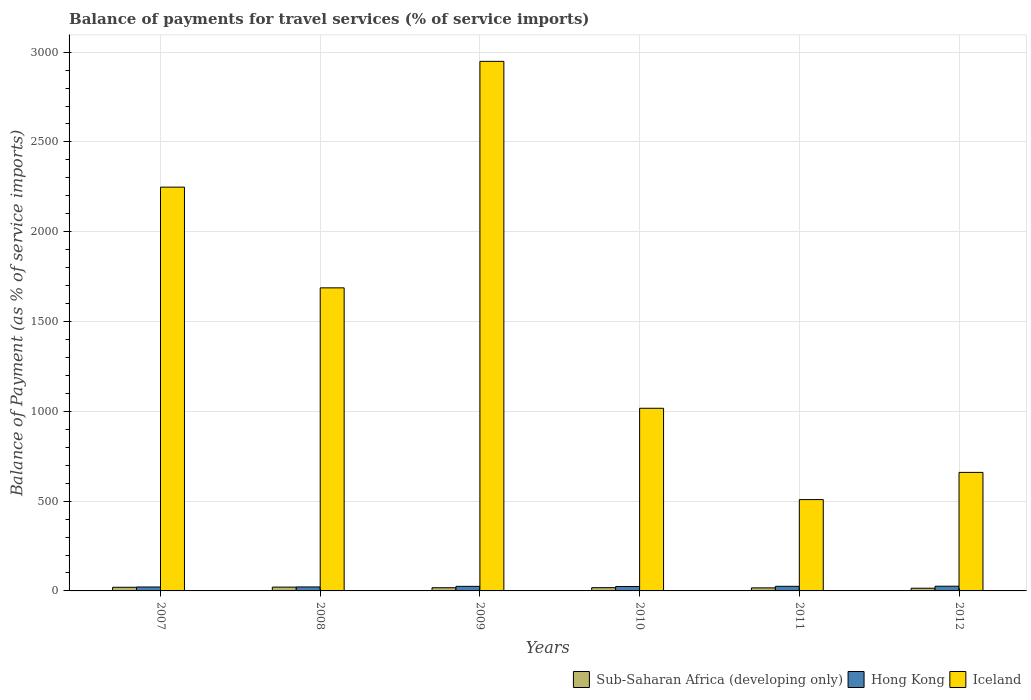How many different coloured bars are there?
Your answer should be very brief. 3. Are the number of bars per tick equal to the number of legend labels?
Your answer should be compact. Yes. How many bars are there on the 5th tick from the left?
Provide a short and direct response. 3. How many bars are there on the 2nd tick from the right?
Give a very brief answer. 3. In how many cases, is the number of bars for a given year not equal to the number of legend labels?
Keep it short and to the point. 0. What is the balance of payments for travel services in Iceland in 2009?
Offer a very short reply. 2948.8. Across all years, what is the maximum balance of payments for travel services in Sub-Saharan Africa (developing only)?
Make the answer very short. 21.18. Across all years, what is the minimum balance of payments for travel services in Hong Kong?
Ensure brevity in your answer.  21.89. In which year was the balance of payments for travel services in Iceland maximum?
Provide a short and direct response. 2009. In which year was the balance of payments for travel services in Hong Kong minimum?
Your answer should be compact. 2007. What is the total balance of payments for travel services in Iceland in the graph?
Make the answer very short. 9070.38. What is the difference between the balance of payments for travel services in Hong Kong in 2010 and that in 2012?
Keep it short and to the point. -1.55. What is the difference between the balance of payments for travel services in Sub-Saharan Africa (developing only) in 2008 and the balance of payments for travel services in Hong Kong in 2010?
Provide a succinct answer. -3.47. What is the average balance of payments for travel services in Sub-Saharan Africa (developing only) per year?
Provide a succinct answer. 18.22. In the year 2007, what is the difference between the balance of payments for travel services in Iceland and balance of payments for travel services in Hong Kong?
Ensure brevity in your answer.  2226.53. What is the ratio of the balance of payments for travel services in Hong Kong in 2007 to that in 2008?
Provide a succinct answer. 0.99. Is the balance of payments for travel services in Sub-Saharan Africa (developing only) in 2007 less than that in 2011?
Offer a very short reply. No. What is the difference between the highest and the second highest balance of payments for travel services in Iceland?
Your answer should be very brief. 700.37. What is the difference between the highest and the lowest balance of payments for travel services in Iceland?
Ensure brevity in your answer.  2440.18. In how many years, is the balance of payments for travel services in Sub-Saharan Africa (developing only) greater than the average balance of payments for travel services in Sub-Saharan Africa (developing only) taken over all years?
Ensure brevity in your answer.  2. Is the sum of the balance of payments for travel services in Hong Kong in 2008 and 2009 greater than the maximum balance of payments for travel services in Iceland across all years?
Provide a succinct answer. No. What does the 1st bar from the left in 2007 represents?
Provide a succinct answer. Sub-Saharan Africa (developing only). Is it the case that in every year, the sum of the balance of payments for travel services in Iceland and balance of payments for travel services in Hong Kong is greater than the balance of payments for travel services in Sub-Saharan Africa (developing only)?
Ensure brevity in your answer.  Yes. Are all the bars in the graph horizontal?
Ensure brevity in your answer.  No. What is the difference between two consecutive major ticks on the Y-axis?
Your response must be concise. 500. Where does the legend appear in the graph?
Make the answer very short. Bottom right. What is the title of the graph?
Give a very brief answer. Balance of payments for travel services (% of service imports). Does "Pakistan" appear as one of the legend labels in the graph?
Your answer should be compact. No. What is the label or title of the Y-axis?
Your answer should be compact. Balance of Payment (as % of service imports). What is the Balance of Payment (as % of service imports) of Sub-Saharan Africa (developing only) in 2007?
Provide a short and direct response. 20.3. What is the Balance of Payment (as % of service imports) of Hong Kong in 2007?
Give a very brief answer. 21.89. What is the Balance of Payment (as % of service imports) of Iceland in 2007?
Provide a short and direct response. 2248.42. What is the Balance of Payment (as % of service imports) of Sub-Saharan Africa (developing only) in 2008?
Offer a terse response. 21.18. What is the Balance of Payment (as % of service imports) of Hong Kong in 2008?
Offer a very short reply. 22.16. What is the Balance of Payment (as % of service imports) in Iceland in 2008?
Offer a terse response. 1687.56. What is the Balance of Payment (as % of service imports) of Sub-Saharan Africa (developing only) in 2009?
Keep it short and to the point. 17.69. What is the Balance of Payment (as % of service imports) of Hong Kong in 2009?
Provide a succinct answer. 25.44. What is the Balance of Payment (as % of service imports) in Iceland in 2009?
Offer a very short reply. 2948.8. What is the Balance of Payment (as % of service imports) of Sub-Saharan Africa (developing only) in 2010?
Give a very brief answer. 18.14. What is the Balance of Payment (as % of service imports) of Hong Kong in 2010?
Provide a short and direct response. 24.66. What is the Balance of Payment (as % of service imports) in Iceland in 2010?
Provide a succinct answer. 1017.05. What is the Balance of Payment (as % of service imports) in Sub-Saharan Africa (developing only) in 2011?
Offer a very short reply. 16.9. What is the Balance of Payment (as % of service imports) in Hong Kong in 2011?
Offer a very short reply. 25.62. What is the Balance of Payment (as % of service imports) of Iceland in 2011?
Make the answer very short. 508.61. What is the Balance of Payment (as % of service imports) in Sub-Saharan Africa (developing only) in 2012?
Offer a terse response. 15.08. What is the Balance of Payment (as % of service imports) of Hong Kong in 2012?
Ensure brevity in your answer.  26.2. What is the Balance of Payment (as % of service imports) in Iceland in 2012?
Your response must be concise. 659.94. Across all years, what is the maximum Balance of Payment (as % of service imports) of Sub-Saharan Africa (developing only)?
Your answer should be very brief. 21.18. Across all years, what is the maximum Balance of Payment (as % of service imports) of Hong Kong?
Provide a succinct answer. 26.2. Across all years, what is the maximum Balance of Payment (as % of service imports) in Iceland?
Give a very brief answer. 2948.8. Across all years, what is the minimum Balance of Payment (as % of service imports) in Sub-Saharan Africa (developing only)?
Your answer should be very brief. 15.08. Across all years, what is the minimum Balance of Payment (as % of service imports) in Hong Kong?
Keep it short and to the point. 21.89. Across all years, what is the minimum Balance of Payment (as % of service imports) in Iceland?
Your response must be concise. 508.61. What is the total Balance of Payment (as % of service imports) in Sub-Saharan Africa (developing only) in the graph?
Give a very brief answer. 109.29. What is the total Balance of Payment (as % of service imports) in Hong Kong in the graph?
Provide a succinct answer. 145.97. What is the total Balance of Payment (as % of service imports) of Iceland in the graph?
Make the answer very short. 9070.38. What is the difference between the Balance of Payment (as % of service imports) in Sub-Saharan Africa (developing only) in 2007 and that in 2008?
Provide a succinct answer. -0.88. What is the difference between the Balance of Payment (as % of service imports) of Hong Kong in 2007 and that in 2008?
Offer a very short reply. -0.27. What is the difference between the Balance of Payment (as % of service imports) of Iceland in 2007 and that in 2008?
Make the answer very short. 560.86. What is the difference between the Balance of Payment (as % of service imports) of Sub-Saharan Africa (developing only) in 2007 and that in 2009?
Your response must be concise. 2.61. What is the difference between the Balance of Payment (as % of service imports) in Hong Kong in 2007 and that in 2009?
Make the answer very short. -3.55. What is the difference between the Balance of Payment (as % of service imports) in Iceland in 2007 and that in 2009?
Provide a succinct answer. -700.37. What is the difference between the Balance of Payment (as % of service imports) of Sub-Saharan Africa (developing only) in 2007 and that in 2010?
Ensure brevity in your answer.  2.16. What is the difference between the Balance of Payment (as % of service imports) of Hong Kong in 2007 and that in 2010?
Offer a very short reply. -2.77. What is the difference between the Balance of Payment (as % of service imports) in Iceland in 2007 and that in 2010?
Make the answer very short. 1231.38. What is the difference between the Balance of Payment (as % of service imports) of Sub-Saharan Africa (developing only) in 2007 and that in 2011?
Offer a terse response. 3.4. What is the difference between the Balance of Payment (as % of service imports) in Hong Kong in 2007 and that in 2011?
Provide a short and direct response. -3.73. What is the difference between the Balance of Payment (as % of service imports) of Iceland in 2007 and that in 2011?
Give a very brief answer. 1739.81. What is the difference between the Balance of Payment (as % of service imports) of Sub-Saharan Africa (developing only) in 2007 and that in 2012?
Your response must be concise. 5.22. What is the difference between the Balance of Payment (as % of service imports) in Hong Kong in 2007 and that in 2012?
Your answer should be compact. -4.31. What is the difference between the Balance of Payment (as % of service imports) of Iceland in 2007 and that in 2012?
Provide a succinct answer. 1588.48. What is the difference between the Balance of Payment (as % of service imports) in Sub-Saharan Africa (developing only) in 2008 and that in 2009?
Ensure brevity in your answer.  3.5. What is the difference between the Balance of Payment (as % of service imports) of Hong Kong in 2008 and that in 2009?
Keep it short and to the point. -3.28. What is the difference between the Balance of Payment (as % of service imports) in Iceland in 2008 and that in 2009?
Make the answer very short. -1261.23. What is the difference between the Balance of Payment (as % of service imports) of Sub-Saharan Africa (developing only) in 2008 and that in 2010?
Ensure brevity in your answer.  3.04. What is the difference between the Balance of Payment (as % of service imports) of Hong Kong in 2008 and that in 2010?
Offer a terse response. -2.49. What is the difference between the Balance of Payment (as % of service imports) in Iceland in 2008 and that in 2010?
Provide a short and direct response. 670.52. What is the difference between the Balance of Payment (as % of service imports) of Sub-Saharan Africa (developing only) in 2008 and that in 2011?
Provide a short and direct response. 4.29. What is the difference between the Balance of Payment (as % of service imports) in Hong Kong in 2008 and that in 2011?
Your answer should be compact. -3.45. What is the difference between the Balance of Payment (as % of service imports) in Iceland in 2008 and that in 2011?
Keep it short and to the point. 1178.95. What is the difference between the Balance of Payment (as % of service imports) in Sub-Saharan Africa (developing only) in 2008 and that in 2012?
Offer a very short reply. 6.1. What is the difference between the Balance of Payment (as % of service imports) in Hong Kong in 2008 and that in 2012?
Ensure brevity in your answer.  -4.04. What is the difference between the Balance of Payment (as % of service imports) of Iceland in 2008 and that in 2012?
Your answer should be very brief. 1027.62. What is the difference between the Balance of Payment (as % of service imports) in Sub-Saharan Africa (developing only) in 2009 and that in 2010?
Provide a short and direct response. -0.45. What is the difference between the Balance of Payment (as % of service imports) in Hong Kong in 2009 and that in 2010?
Offer a very short reply. 0.79. What is the difference between the Balance of Payment (as % of service imports) of Iceland in 2009 and that in 2010?
Ensure brevity in your answer.  1931.75. What is the difference between the Balance of Payment (as % of service imports) of Sub-Saharan Africa (developing only) in 2009 and that in 2011?
Give a very brief answer. 0.79. What is the difference between the Balance of Payment (as % of service imports) of Hong Kong in 2009 and that in 2011?
Ensure brevity in your answer.  -0.17. What is the difference between the Balance of Payment (as % of service imports) of Iceland in 2009 and that in 2011?
Your response must be concise. 2440.18. What is the difference between the Balance of Payment (as % of service imports) in Sub-Saharan Africa (developing only) in 2009 and that in 2012?
Make the answer very short. 2.6. What is the difference between the Balance of Payment (as % of service imports) in Hong Kong in 2009 and that in 2012?
Make the answer very short. -0.76. What is the difference between the Balance of Payment (as % of service imports) of Iceland in 2009 and that in 2012?
Your answer should be compact. 2288.86. What is the difference between the Balance of Payment (as % of service imports) in Sub-Saharan Africa (developing only) in 2010 and that in 2011?
Your answer should be compact. 1.24. What is the difference between the Balance of Payment (as % of service imports) of Hong Kong in 2010 and that in 2011?
Your answer should be compact. -0.96. What is the difference between the Balance of Payment (as % of service imports) in Iceland in 2010 and that in 2011?
Your answer should be compact. 508.44. What is the difference between the Balance of Payment (as % of service imports) of Sub-Saharan Africa (developing only) in 2010 and that in 2012?
Ensure brevity in your answer.  3.06. What is the difference between the Balance of Payment (as % of service imports) in Hong Kong in 2010 and that in 2012?
Offer a terse response. -1.55. What is the difference between the Balance of Payment (as % of service imports) in Iceland in 2010 and that in 2012?
Your answer should be very brief. 357.11. What is the difference between the Balance of Payment (as % of service imports) of Sub-Saharan Africa (developing only) in 2011 and that in 2012?
Offer a very short reply. 1.81. What is the difference between the Balance of Payment (as % of service imports) of Hong Kong in 2011 and that in 2012?
Provide a short and direct response. -0.59. What is the difference between the Balance of Payment (as % of service imports) of Iceland in 2011 and that in 2012?
Provide a succinct answer. -151.33. What is the difference between the Balance of Payment (as % of service imports) of Sub-Saharan Africa (developing only) in 2007 and the Balance of Payment (as % of service imports) of Hong Kong in 2008?
Offer a very short reply. -1.86. What is the difference between the Balance of Payment (as % of service imports) of Sub-Saharan Africa (developing only) in 2007 and the Balance of Payment (as % of service imports) of Iceland in 2008?
Offer a terse response. -1667.26. What is the difference between the Balance of Payment (as % of service imports) of Hong Kong in 2007 and the Balance of Payment (as % of service imports) of Iceland in 2008?
Give a very brief answer. -1665.67. What is the difference between the Balance of Payment (as % of service imports) of Sub-Saharan Africa (developing only) in 2007 and the Balance of Payment (as % of service imports) of Hong Kong in 2009?
Give a very brief answer. -5.14. What is the difference between the Balance of Payment (as % of service imports) in Sub-Saharan Africa (developing only) in 2007 and the Balance of Payment (as % of service imports) in Iceland in 2009?
Your answer should be compact. -2928.5. What is the difference between the Balance of Payment (as % of service imports) of Hong Kong in 2007 and the Balance of Payment (as % of service imports) of Iceland in 2009?
Your response must be concise. -2926.91. What is the difference between the Balance of Payment (as % of service imports) of Sub-Saharan Africa (developing only) in 2007 and the Balance of Payment (as % of service imports) of Hong Kong in 2010?
Provide a succinct answer. -4.36. What is the difference between the Balance of Payment (as % of service imports) of Sub-Saharan Africa (developing only) in 2007 and the Balance of Payment (as % of service imports) of Iceland in 2010?
Your answer should be very brief. -996.75. What is the difference between the Balance of Payment (as % of service imports) of Hong Kong in 2007 and the Balance of Payment (as % of service imports) of Iceland in 2010?
Make the answer very short. -995.16. What is the difference between the Balance of Payment (as % of service imports) in Sub-Saharan Africa (developing only) in 2007 and the Balance of Payment (as % of service imports) in Hong Kong in 2011?
Your response must be concise. -5.32. What is the difference between the Balance of Payment (as % of service imports) of Sub-Saharan Africa (developing only) in 2007 and the Balance of Payment (as % of service imports) of Iceland in 2011?
Ensure brevity in your answer.  -488.31. What is the difference between the Balance of Payment (as % of service imports) in Hong Kong in 2007 and the Balance of Payment (as % of service imports) in Iceland in 2011?
Give a very brief answer. -486.72. What is the difference between the Balance of Payment (as % of service imports) of Sub-Saharan Africa (developing only) in 2007 and the Balance of Payment (as % of service imports) of Hong Kong in 2012?
Your answer should be very brief. -5.9. What is the difference between the Balance of Payment (as % of service imports) in Sub-Saharan Africa (developing only) in 2007 and the Balance of Payment (as % of service imports) in Iceland in 2012?
Your answer should be compact. -639.64. What is the difference between the Balance of Payment (as % of service imports) of Hong Kong in 2007 and the Balance of Payment (as % of service imports) of Iceland in 2012?
Provide a short and direct response. -638.05. What is the difference between the Balance of Payment (as % of service imports) in Sub-Saharan Africa (developing only) in 2008 and the Balance of Payment (as % of service imports) in Hong Kong in 2009?
Provide a succinct answer. -4.26. What is the difference between the Balance of Payment (as % of service imports) in Sub-Saharan Africa (developing only) in 2008 and the Balance of Payment (as % of service imports) in Iceland in 2009?
Your response must be concise. -2927.61. What is the difference between the Balance of Payment (as % of service imports) in Hong Kong in 2008 and the Balance of Payment (as % of service imports) in Iceland in 2009?
Provide a short and direct response. -2926.63. What is the difference between the Balance of Payment (as % of service imports) in Sub-Saharan Africa (developing only) in 2008 and the Balance of Payment (as % of service imports) in Hong Kong in 2010?
Your answer should be compact. -3.47. What is the difference between the Balance of Payment (as % of service imports) of Sub-Saharan Africa (developing only) in 2008 and the Balance of Payment (as % of service imports) of Iceland in 2010?
Provide a short and direct response. -995.86. What is the difference between the Balance of Payment (as % of service imports) of Hong Kong in 2008 and the Balance of Payment (as % of service imports) of Iceland in 2010?
Offer a very short reply. -994.88. What is the difference between the Balance of Payment (as % of service imports) in Sub-Saharan Africa (developing only) in 2008 and the Balance of Payment (as % of service imports) in Hong Kong in 2011?
Offer a terse response. -4.43. What is the difference between the Balance of Payment (as % of service imports) of Sub-Saharan Africa (developing only) in 2008 and the Balance of Payment (as % of service imports) of Iceland in 2011?
Offer a terse response. -487.43. What is the difference between the Balance of Payment (as % of service imports) in Hong Kong in 2008 and the Balance of Payment (as % of service imports) in Iceland in 2011?
Offer a very short reply. -486.45. What is the difference between the Balance of Payment (as % of service imports) of Sub-Saharan Africa (developing only) in 2008 and the Balance of Payment (as % of service imports) of Hong Kong in 2012?
Your answer should be very brief. -5.02. What is the difference between the Balance of Payment (as % of service imports) in Sub-Saharan Africa (developing only) in 2008 and the Balance of Payment (as % of service imports) in Iceland in 2012?
Your answer should be compact. -638.76. What is the difference between the Balance of Payment (as % of service imports) in Hong Kong in 2008 and the Balance of Payment (as % of service imports) in Iceland in 2012?
Provide a succinct answer. -637.78. What is the difference between the Balance of Payment (as % of service imports) in Sub-Saharan Africa (developing only) in 2009 and the Balance of Payment (as % of service imports) in Hong Kong in 2010?
Offer a terse response. -6.97. What is the difference between the Balance of Payment (as % of service imports) of Sub-Saharan Africa (developing only) in 2009 and the Balance of Payment (as % of service imports) of Iceland in 2010?
Your answer should be compact. -999.36. What is the difference between the Balance of Payment (as % of service imports) of Hong Kong in 2009 and the Balance of Payment (as % of service imports) of Iceland in 2010?
Give a very brief answer. -991.6. What is the difference between the Balance of Payment (as % of service imports) of Sub-Saharan Africa (developing only) in 2009 and the Balance of Payment (as % of service imports) of Hong Kong in 2011?
Offer a terse response. -7.93. What is the difference between the Balance of Payment (as % of service imports) of Sub-Saharan Africa (developing only) in 2009 and the Balance of Payment (as % of service imports) of Iceland in 2011?
Provide a short and direct response. -490.92. What is the difference between the Balance of Payment (as % of service imports) of Hong Kong in 2009 and the Balance of Payment (as % of service imports) of Iceland in 2011?
Provide a short and direct response. -483.17. What is the difference between the Balance of Payment (as % of service imports) of Sub-Saharan Africa (developing only) in 2009 and the Balance of Payment (as % of service imports) of Hong Kong in 2012?
Your answer should be compact. -8.52. What is the difference between the Balance of Payment (as % of service imports) of Sub-Saharan Africa (developing only) in 2009 and the Balance of Payment (as % of service imports) of Iceland in 2012?
Offer a very short reply. -642.25. What is the difference between the Balance of Payment (as % of service imports) in Hong Kong in 2009 and the Balance of Payment (as % of service imports) in Iceland in 2012?
Provide a succinct answer. -634.5. What is the difference between the Balance of Payment (as % of service imports) in Sub-Saharan Africa (developing only) in 2010 and the Balance of Payment (as % of service imports) in Hong Kong in 2011?
Give a very brief answer. -7.48. What is the difference between the Balance of Payment (as % of service imports) of Sub-Saharan Africa (developing only) in 2010 and the Balance of Payment (as % of service imports) of Iceland in 2011?
Make the answer very short. -490.47. What is the difference between the Balance of Payment (as % of service imports) of Hong Kong in 2010 and the Balance of Payment (as % of service imports) of Iceland in 2011?
Give a very brief answer. -483.96. What is the difference between the Balance of Payment (as % of service imports) of Sub-Saharan Africa (developing only) in 2010 and the Balance of Payment (as % of service imports) of Hong Kong in 2012?
Keep it short and to the point. -8.06. What is the difference between the Balance of Payment (as % of service imports) of Sub-Saharan Africa (developing only) in 2010 and the Balance of Payment (as % of service imports) of Iceland in 2012?
Ensure brevity in your answer.  -641.8. What is the difference between the Balance of Payment (as % of service imports) in Hong Kong in 2010 and the Balance of Payment (as % of service imports) in Iceland in 2012?
Offer a very short reply. -635.28. What is the difference between the Balance of Payment (as % of service imports) of Sub-Saharan Africa (developing only) in 2011 and the Balance of Payment (as % of service imports) of Hong Kong in 2012?
Make the answer very short. -9.31. What is the difference between the Balance of Payment (as % of service imports) in Sub-Saharan Africa (developing only) in 2011 and the Balance of Payment (as % of service imports) in Iceland in 2012?
Offer a very short reply. -643.04. What is the difference between the Balance of Payment (as % of service imports) in Hong Kong in 2011 and the Balance of Payment (as % of service imports) in Iceland in 2012?
Offer a very short reply. -634.32. What is the average Balance of Payment (as % of service imports) in Sub-Saharan Africa (developing only) per year?
Make the answer very short. 18.22. What is the average Balance of Payment (as % of service imports) in Hong Kong per year?
Make the answer very short. 24.33. What is the average Balance of Payment (as % of service imports) in Iceland per year?
Your response must be concise. 1511.73. In the year 2007, what is the difference between the Balance of Payment (as % of service imports) of Sub-Saharan Africa (developing only) and Balance of Payment (as % of service imports) of Hong Kong?
Provide a succinct answer. -1.59. In the year 2007, what is the difference between the Balance of Payment (as % of service imports) of Sub-Saharan Africa (developing only) and Balance of Payment (as % of service imports) of Iceland?
Offer a very short reply. -2228.12. In the year 2007, what is the difference between the Balance of Payment (as % of service imports) of Hong Kong and Balance of Payment (as % of service imports) of Iceland?
Give a very brief answer. -2226.53. In the year 2008, what is the difference between the Balance of Payment (as % of service imports) in Sub-Saharan Africa (developing only) and Balance of Payment (as % of service imports) in Hong Kong?
Provide a succinct answer. -0.98. In the year 2008, what is the difference between the Balance of Payment (as % of service imports) in Sub-Saharan Africa (developing only) and Balance of Payment (as % of service imports) in Iceland?
Keep it short and to the point. -1666.38. In the year 2008, what is the difference between the Balance of Payment (as % of service imports) of Hong Kong and Balance of Payment (as % of service imports) of Iceland?
Your answer should be very brief. -1665.4. In the year 2009, what is the difference between the Balance of Payment (as % of service imports) in Sub-Saharan Africa (developing only) and Balance of Payment (as % of service imports) in Hong Kong?
Your answer should be compact. -7.75. In the year 2009, what is the difference between the Balance of Payment (as % of service imports) of Sub-Saharan Africa (developing only) and Balance of Payment (as % of service imports) of Iceland?
Your answer should be compact. -2931.11. In the year 2009, what is the difference between the Balance of Payment (as % of service imports) of Hong Kong and Balance of Payment (as % of service imports) of Iceland?
Offer a very short reply. -2923.35. In the year 2010, what is the difference between the Balance of Payment (as % of service imports) in Sub-Saharan Africa (developing only) and Balance of Payment (as % of service imports) in Hong Kong?
Your answer should be compact. -6.51. In the year 2010, what is the difference between the Balance of Payment (as % of service imports) of Sub-Saharan Africa (developing only) and Balance of Payment (as % of service imports) of Iceland?
Give a very brief answer. -998.9. In the year 2010, what is the difference between the Balance of Payment (as % of service imports) in Hong Kong and Balance of Payment (as % of service imports) in Iceland?
Your answer should be compact. -992.39. In the year 2011, what is the difference between the Balance of Payment (as % of service imports) in Sub-Saharan Africa (developing only) and Balance of Payment (as % of service imports) in Hong Kong?
Give a very brief answer. -8.72. In the year 2011, what is the difference between the Balance of Payment (as % of service imports) in Sub-Saharan Africa (developing only) and Balance of Payment (as % of service imports) in Iceland?
Your answer should be very brief. -491.71. In the year 2011, what is the difference between the Balance of Payment (as % of service imports) in Hong Kong and Balance of Payment (as % of service imports) in Iceland?
Provide a succinct answer. -482.99. In the year 2012, what is the difference between the Balance of Payment (as % of service imports) of Sub-Saharan Africa (developing only) and Balance of Payment (as % of service imports) of Hong Kong?
Provide a short and direct response. -11.12. In the year 2012, what is the difference between the Balance of Payment (as % of service imports) in Sub-Saharan Africa (developing only) and Balance of Payment (as % of service imports) in Iceland?
Offer a very short reply. -644.86. In the year 2012, what is the difference between the Balance of Payment (as % of service imports) in Hong Kong and Balance of Payment (as % of service imports) in Iceland?
Provide a succinct answer. -633.74. What is the ratio of the Balance of Payment (as % of service imports) of Sub-Saharan Africa (developing only) in 2007 to that in 2008?
Offer a very short reply. 0.96. What is the ratio of the Balance of Payment (as % of service imports) in Hong Kong in 2007 to that in 2008?
Your answer should be very brief. 0.99. What is the ratio of the Balance of Payment (as % of service imports) in Iceland in 2007 to that in 2008?
Your answer should be very brief. 1.33. What is the ratio of the Balance of Payment (as % of service imports) in Sub-Saharan Africa (developing only) in 2007 to that in 2009?
Provide a succinct answer. 1.15. What is the ratio of the Balance of Payment (as % of service imports) of Hong Kong in 2007 to that in 2009?
Your response must be concise. 0.86. What is the ratio of the Balance of Payment (as % of service imports) of Iceland in 2007 to that in 2009?
Make the answer very short. 0.76. What is the ratio of the Balance of Payment (as % of service imports) in Sub-Saharan Africa (developing only) in 2007 to that in 2010?
Provide a short and direct response. 1.12. What is the ratio of the Balance of Payment (as % of service imports) in Hong Kong in 2007 to that in 2010?
Your response must be concise. 0.89. What is the ratio of the Balance of Payment (as % of service imports) of Iceland in 2007 to that in 2010?
Your response must be concise. 2.21. What is the ratio of the Balance of Payment (as % of service imports) in Sub-Saharan Africa (developing only) in 2007 to that in 2011?
Keep it short and to the point. 1.2. What is the ratio of the Balance of Payment (as % of service imports) of Hong Kong in 2007 to that in 2011?
Provide a succinct answer. 0.85. What is the ratio of the Balance of Payment (as % of service imports) of Iceland in 2007 to that in 2011?
Ensure brevity in your answer.  4.42. What is the ratio of the Balance of Payment (as % of service imports) of Sub-Saharan Africa (developing only) in 2007 to that in 2012?
Offer a very short reply. 1.35. What is the ratio of the Balance of Payment (as % of service imports) in Hong Kong in 2007 to that in 2012?
Ensure brevity in your answer.  0.84. What is the ratio of the Balance of Payment (as % of service imports) in Iceland in 2007 to that in 2012?
Offer a very short reply. 3.41. What is the ratio of the Balance of Payment (as % of service imports) in Sub-Saharan Africa (developing only) in 2008 to that in 2009?
Provide a short and direct response. 1.2. What is the ratio of the Balance of Payment (as % of service imports) in Hong Kong in 2008 to that in 2009?
Provide a succinct answer. 0.87. What is the ratio of the Balance of Payment (as % of service imports) of Iceland in 2008 to that in 2009?
Ensure brevity in your answer.  0.57. What is the ratio of the Balance of Payment (as % of service imports) in Sub-Saharan Africa (developing only) in 2008 to that in 2010?
Your response must be concise. 1.17. What is the ratio of the Balance of Payment (as % of service imports) of Hong Kong in 2008 to that in 2010?
Ensure brevity in your answer.  0.9. What is the ratio of the Balance of Payment (as % of service imports) in Iceland in 2008 to that in 2010?
Offer a very short reply. 1.66. What is the ratio of the Balance of Payment (as % of service imports) in Sub-Saharan Africa (developing only) in 2008 to that in 2011?
Keep it short and to the point. 1.25. What is the ratio of the Balance of Payment (as % of service imports) of Hong Kong in 2008 to that in 2011?
Your answer should be compact. 0.87. What is the ratio of the Balance of Payment (as % of service imports) of Iceland in 2008 to that in 2011?
Offer a very short reply. 3.32. What is the ratio of the Balance of Payment (as % of service imports) of Sub-Saharan Africa (developing only) in 2008 to that in 2012?
Keep it short and to the point. 1.4. What is the ratio of the Balance of Payment (as % of service imports) in Hong Kong in 2008 to that in 2012?
Provide a short and direct response. 0.85. What is the ratio of the Balance of Payment (as % of service imports) of Iceland in 2008 to that in 2012?
Make the answer very short. 2.56. What is the ratio of the Balance of Payment (as % of service imports) in Sub-Saharan Africa (developing only) in 2009 to that in 2010?
Offer a terse response. 0.97. What is the ratio of the Balance of Payment (as % of service imports) in Hong Kong in 2009 to that in 2010?
Provide a short and direct response. 1.03. What is the ratio of the Balance of Payment (as % of service imports) of Iceland in 2009 to that in 2010?
Keep it short and to the point. 2.9. What is the ratio of the Balance of Payment (as % of service imports) of Sub-Saharan Africa (developing only) in 2009 to that in 2011?
Your answer should be compact. 1.05. What is the ratio of the Balance of Payment (as % of service imports) in Hong Kong in 2009 to that in 2011?
Provide a short and direct response. 0.99. What is the ratio of the Balance of Payment (as % of service imports) in Iceland in 2009 to that in 2011?
Your response must be concise. 5.8. What is the ratio of the Balance of Payment (as % of service imports) of Sub-Saharan Africa (developing only) in 2009 to that in 2012?
Your response must be concise. 1.17. What is the ratio of the Balance of Payment (as % of service imports) in Iceland in 2009 to that in 2012?
Your response must be concise. 4.47. What is the ratio of the Balance of Payment (as % of service imports) of Sub-Saharan Africa (developing only) in 2010 to that in 2011?
Offer a very short reply. 1.07. What is the ratio of the Balance of Payment (as % of service imports) in Hong Kong in 2010 to that in 2011?
Ensure brevity in your answer.  0.96. What is the ratio of the Balance of Payment (as % of service imports) in Iceland in 2010 to that in 2011?
Provide a short and direct response. 2. What is the ratio of the Balance of Payment (as % of service imports) of Sub-Saharan Africa (developing only) in 2010 to that in 2012?
Offer a terse response. 1.2. What is the ratio of the Balance of Payment (as % of service imports) of Hong Kong in 2010 to that in 2012?
Ensure brevity in your answer.  0.94. What is the ratio of the Balance of Payment (as % of service imports) in Iceland in 2010 to that in 2012?
Give a very brief answer. 1.54. What is the ratio of the Balance of Payment (as % of service imports) in Sub-Saharan Africa (developing only) in 2011 to that in 2012?
Give a very brief answer. 1.12. What is the ratio of the Balance of Payment (as % of service imports) of Hong Kong in 2011 to that in 2012?
Your response must be concise. 0.98. What is the ratio of the Balance of Payment (as % of service imports) of Iceland in 2011 to that in 2012?
Make the answer very short. 0.77. What is the difference between the highest and the second highest Balance of Payment (as % of service imports) of Sub-Saharan Africa (developing only)?
Keep it short and to the point. 0.88. What is the difference between the highest and the second highest Balance of Payment (as % of service imports) in Hong Kong?
Offer a very short reply. 0.59. What is the difference between the highest and the second highest Balance of Payment (as % of service imports) in Iceland?
Offer a terse response. 700.37. What is the difference between the highest and the lowest Balance of Payment (as % of service imports) of Sub-Saharan Africa (developing only)?
Your response must be concise. 6.1. What is the difference between the highest and the lowest Balance of Payment (as % of service imports) in Hong Kong?
Your answer should be compact. 4.31. What is the difference between the highest and the lowest Balance of Payment (as % of service imports) of Iceland?
Your response must be concise. 2440.18. 